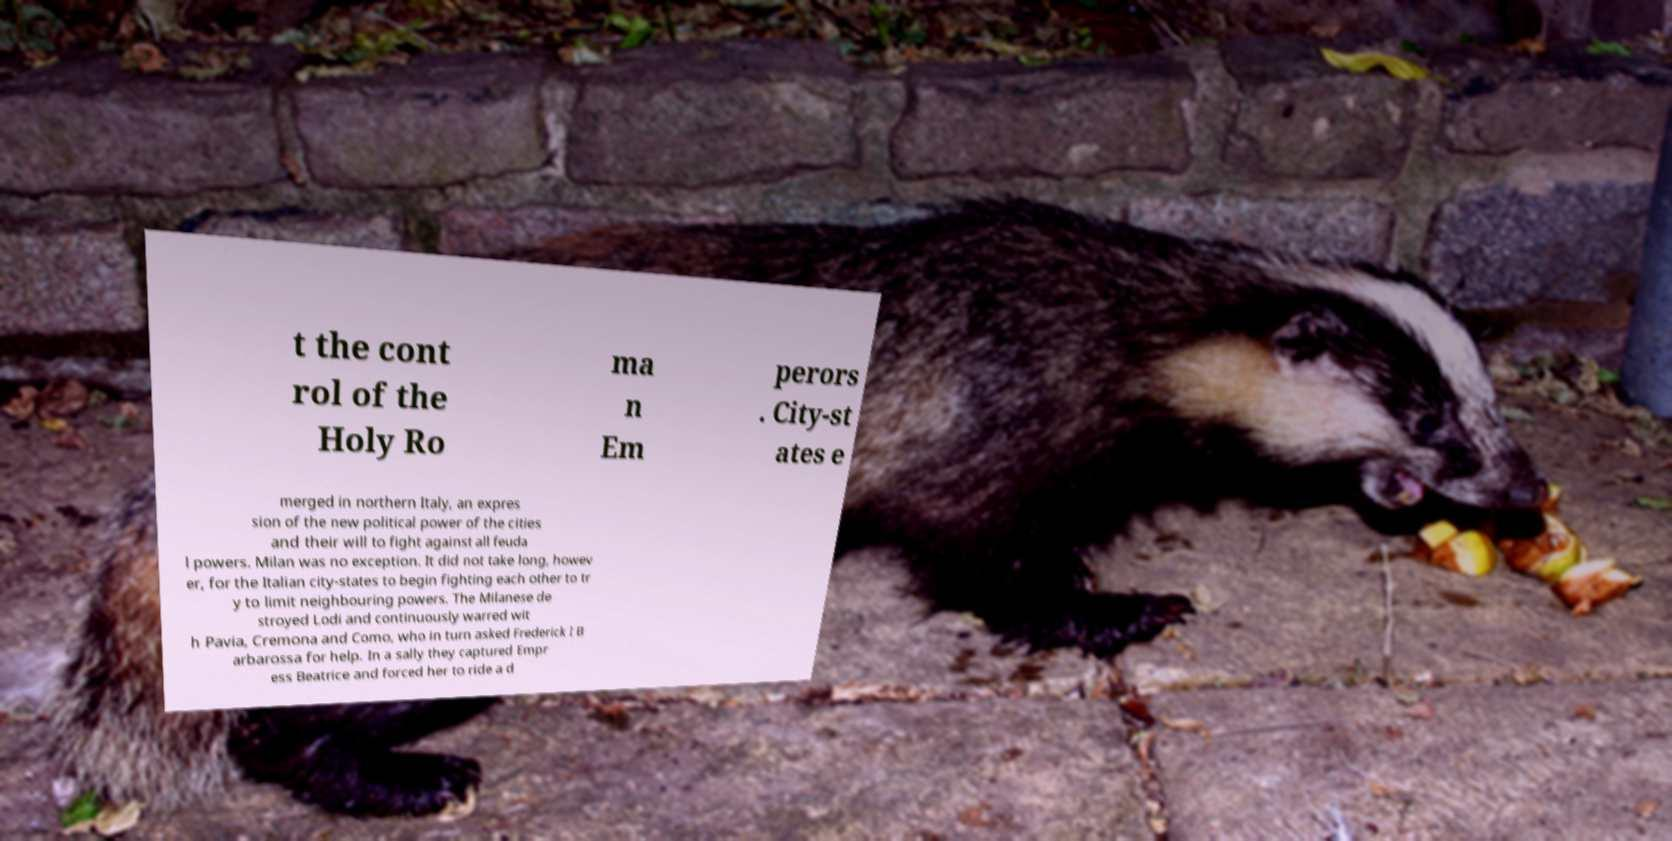Please identify and transcribe the text found in this image. t the cont rol of the Holy Ro ma n Em perors . City-st ates e merged in northern Italy, an expres sion of the new political power of the cities and their will to fight against all feuda l powers. Milan was no exception. It did not take long, howev er, for the Italian city-states to begin fighting each other to tr y to limit neighbouring powers. The Milanese de stroyed Lodi and continuously warred wit h Pavia, Cremona and Como, who in turn asked Frederick I B arbarossa for help. In a sally they captured Empr ess Beatrice and forced her to ride a d 